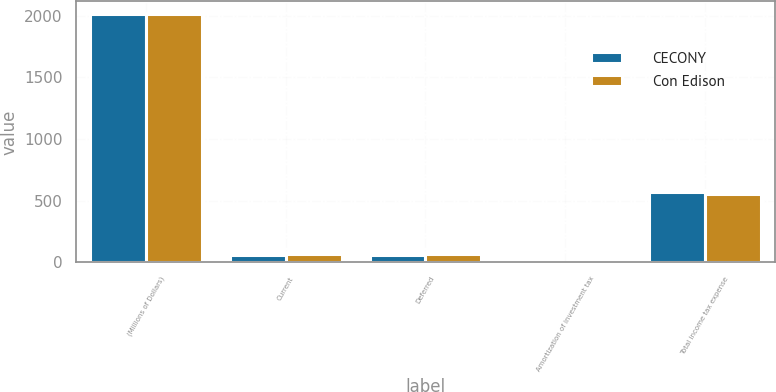Convert chart. <chart><loc_0><loc_0><loc_500><loc_500><stacked_bar_chart><ecel><fcel>(Millions of Dollars)<fcel>Current<fcel>Deferred<fcel>Amortization of investment tax<fcel>Total income tax expense<nl><fcel>CECONY<fcel>2014<fcel>59<fcel>61<fcel>6<fcel>568<nl><fcel>Con Edison<fcel>2014<fcel>66<fcel>65<fcel>5<fcel>555<nl></chart> 